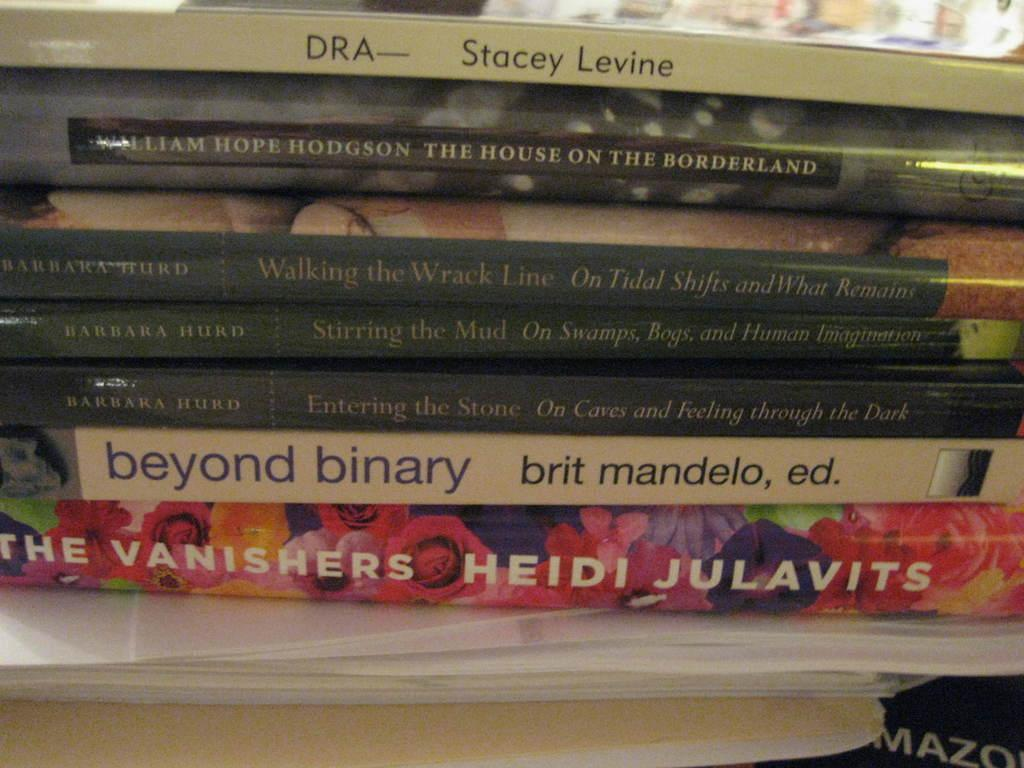<image>
Create a compact narrative representing the image presented. A stack of books includes titles such as The House on the Borderland, The Vanishers and Beyond Binary. 